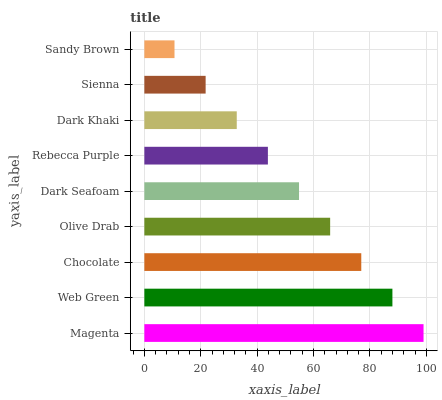Is Sandy Brown the minimum?
Answer yes or no. Yes. Is Magenta the maximum?
Answer yes or no. Yes. Is Web Green the minimum?
Answer yes or no. No. Is Web Green the maximum?
Answer yes or no. No. Is Magenta greater than Web Green?
Answer yes or no. Yes. Is Web Green less than Magenta?
Answer yes or no. Yes. Is Web Green greater than Magenta?
Answer yes or no. No. Is Magenta less than Web Green?
Answer yes or no. No. Is Dark Seafoam the high median?
Answer yes or no. Yes. Is Dark Seafoam the low median?
Answer yes or no. Yes. Is Dark Khaki the high median?
Answer yes or no. No. Is Olive Drab the low median?
Answer yes or no. No. 